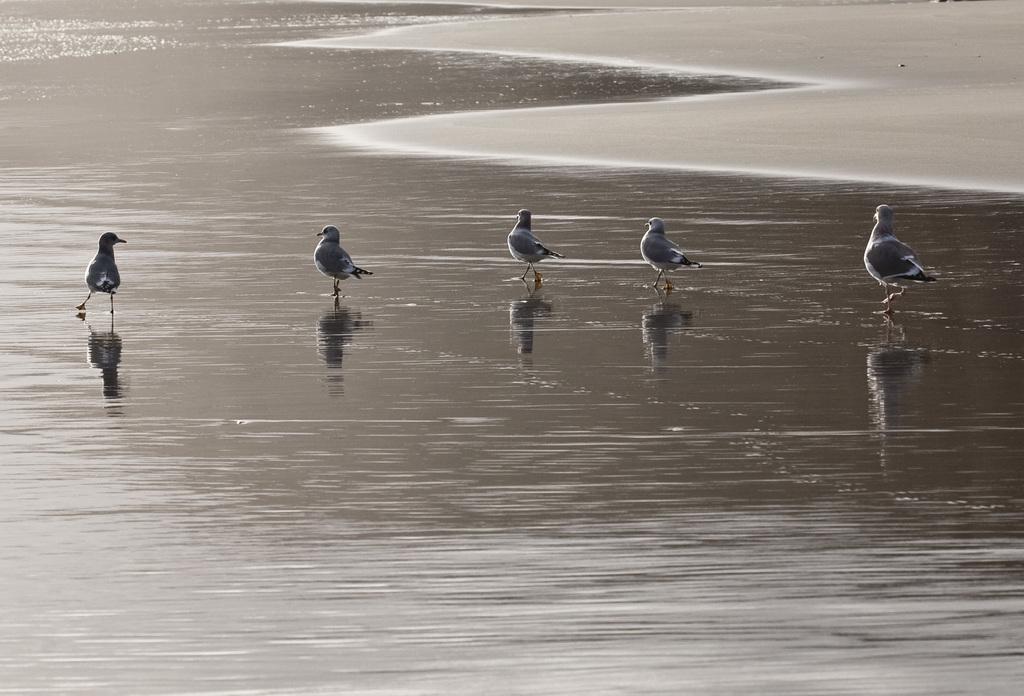Describe this image in one or two sentences. In this picture we can see birds in the water. At the top of the image, there is the sand. On the water, we can see the reflections of the birds. 